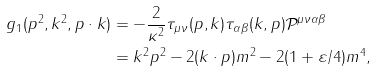<formula> <loc_0><loc_0><loc_500><loc_500>g _ { 1 } ( p ^ { 2 } , k ^ { 2 } , p \cdot k ) & = - \frac { 2 } { \kappa ^ { 2 } } \tau _ { \mu \nu } ( p , k ) \tau _ { \alpha \beta } ( k , p ) \mathcal { P } ^ { \mu \nu \alpha \beta } \\ & = k ^ { 2 } p ^ { 2 } - 2 ( k \cdot p ) m ^ { 2 } - 2 ( 1 + \varepsilon / 4 ) m ^ { 4 } ,</formula> 